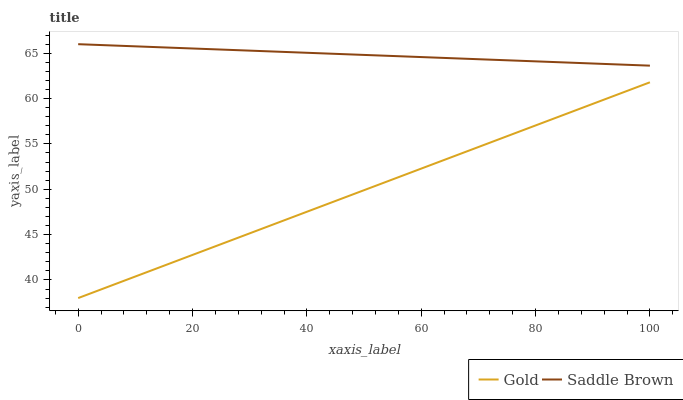Does Gold have the minimum area under the curve?
Answer yes or no. Yes. Does Saddle Brown have the maximum area under the curve?
Answer yes or no. Yes. Does Gold have the maximum area under the curve?
Answer yes or no. No. Is Gold the smoothest?
Answer yes or no. Yes. Is Saddle Brown the roughest?
Answer yes or no. Yes. Is Gold the roughest?
Answer yes or no. No. Does Saddle Brown have the highest value?
Answer yes or no. Yes. Does Gold have the highest value?
Answer yes or no. No. Is Gold less than Saddle Brown?
Answer yes or no. Yes. Is Saddle Brown greater than Gold?
Answer yes or no. Yes. Does Gold intersect Saddle Brown?
Answer yes or no. No. 